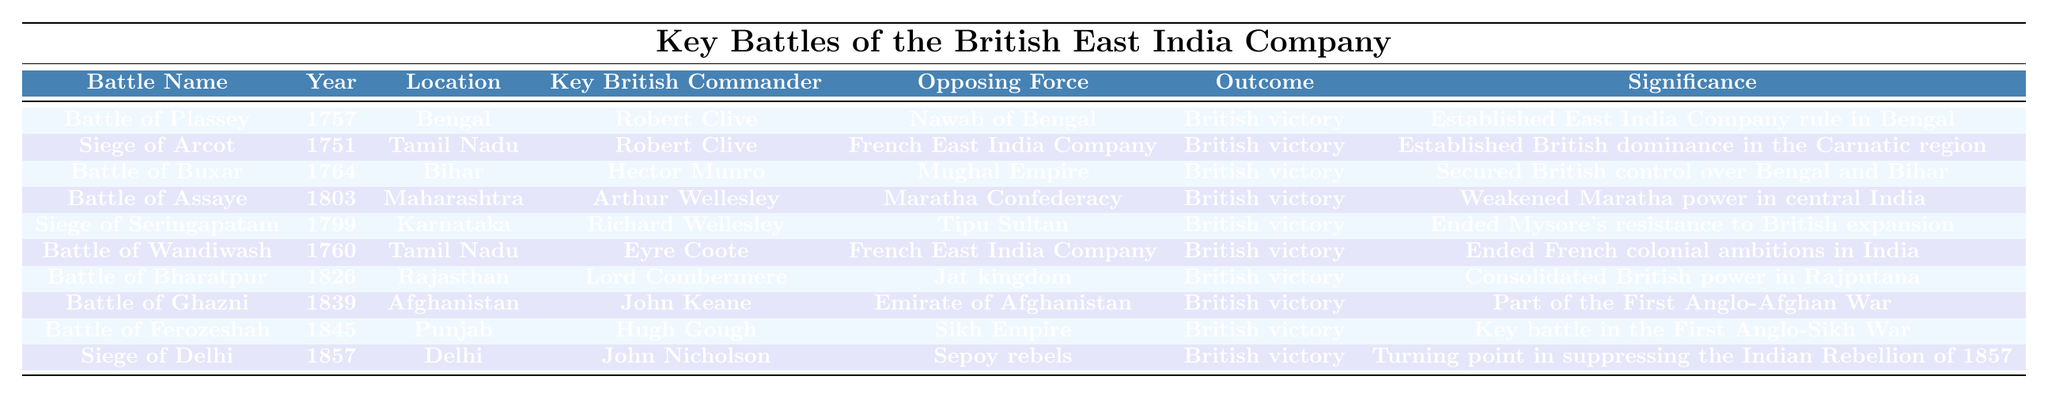What was the outcome of the Battle of Plassey? The table indicates that the Battle of Plassey had an outcome of "British victory."
Answer: British victory Who commanded the British forces in the Battle of Wandiwash? According to the table, the Key British Commander in the Battle of Wandiwash was "Eyre Coote."
Answer: Eyre Coote In which year did the Siege of Delhi take place? The table lists the year for the Siege of Delhi as "1857."
Answer: 1857 Which battle had the significance of ending Mysore's resistance to British expansion? The Siege of Seringapatam is noted in the table to have the significance of ending Mysore's resistance to British expansion.
Answer: Siege of Seringapatam How many battles occurred in Tamil Nadu? By examining the locations, I can identify that there are two battles listed in Tamil Nadu: the Siege of Arcot and the Battle of Wandiwash.
Answer: 2 Was the Battle of Ferozeshah part of a larger conflict? Yes, the table indicates that the Battle of Ferozeshah was a key battle in the First Anglo-Sikh War, thus confirming it was part of a larger conflict.
Answer: Yes Which opposing force did Robert Clive confront in the Siege of Arcot? According to the table, Robert Clive faced the French East India Company in the Siege of Arcot.
Answer: French East India Company What is the significance of the Battle of Ghazni? The table indicates that the significance of the Battle of Ghazni was its involvement in the First Anglo-Afghan War.
Answer: Part of the First Anglo-Afghan War Which battle took place last in chronological order according to the table? By checking the years listed, the last battle in chronological order is the Siege of Delhi in 1857.
Answer: Siege of Delhi How many battles were won by the British in the list? The table shows that all the battles listed resulted in a British victory, totaling 10 battles.
Answer: 10 Which battle resulted in the consolidation of British power in Rajputana? The table notes that the Battle of Bharatpur led to the consolidation of British power in Rajputana.
Answer: Battle of Bharatpur 